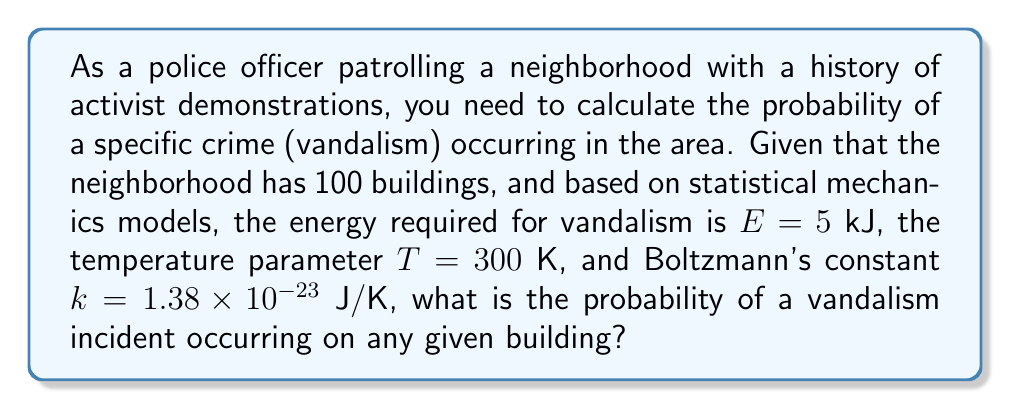Help me with this question. To solve this problem, we'll use the Boltzmann distribution from statistical mechanics:

1) The probability of a state with energy $E$ is given by:

   $$P(E) = \frac{1}{Z} e^{-E/kT}$$

   where $Z$ is the partition function.

2) We don't need to calculate $Z$ explicitly, as we're interested in the relative probability of vandalism occurring vs. not occurring.

3) Convert the energy to Joules: $E = 5 \text{ kJ} = 5000 \text{ J}$

4) Calculate the exponent:

   $$\frac{E}{kT} = \frac{5000}{(1.38 \times 10^{-23})(300)} = 1.21 \times 10^{21}$$

5) The probability of vandalism is then:

   $$P(\text{vandalism}) = e^{-1.21 \times 10^{21}}$$

6) This is an extremely small number, effectively zero for practical purposes.

7) The probability of no vandalism is therefore essentially 1.

8) For any given building, the probability of vandalism is:

   $$P(\text{vandalism per building}) = \frac{e^{-1.21 \times 10^{21}}}{100}$$
Answer: $\frac{e^{-1.21 \times 10^{21}}}{100}$ (effectively 0) 